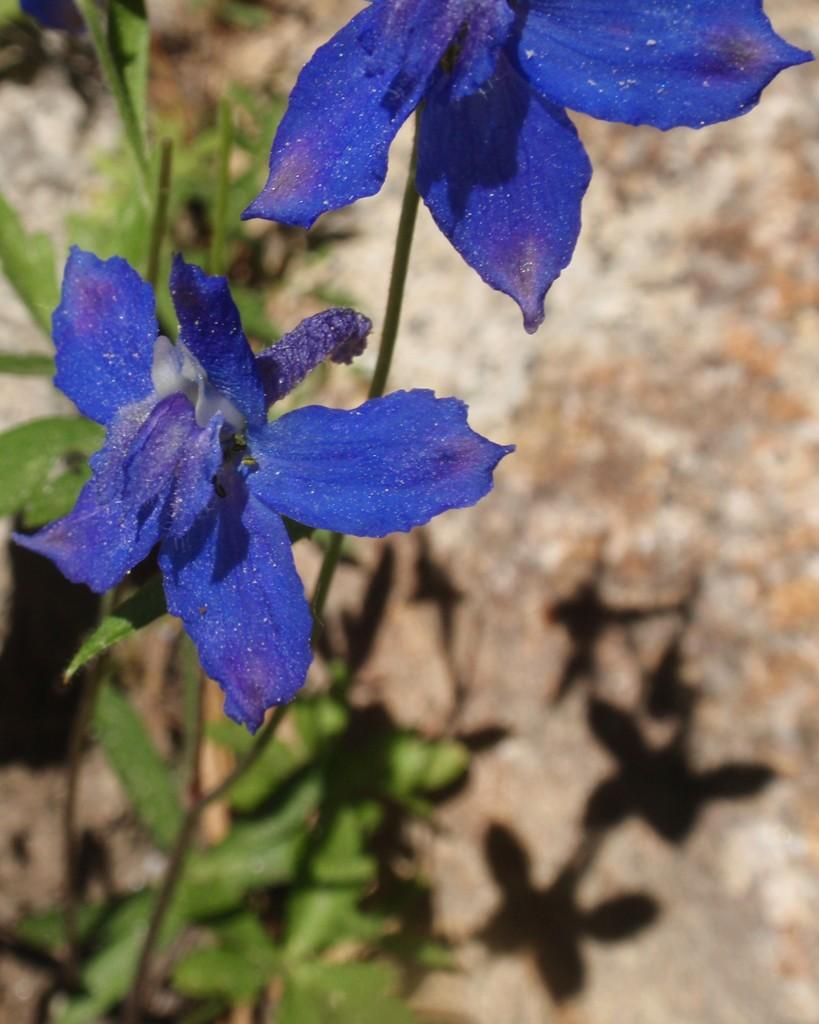What type of living organisms can be seen in the image? Plants can be seen in the image. What specific feature of the plants is visible? The plants have flowers. What color are the flowers? The flowers are violet in color. How much wealth is represented by the violet flowers in the image? The image does not convey any information about wealth, so it cannot be determined from the image. 